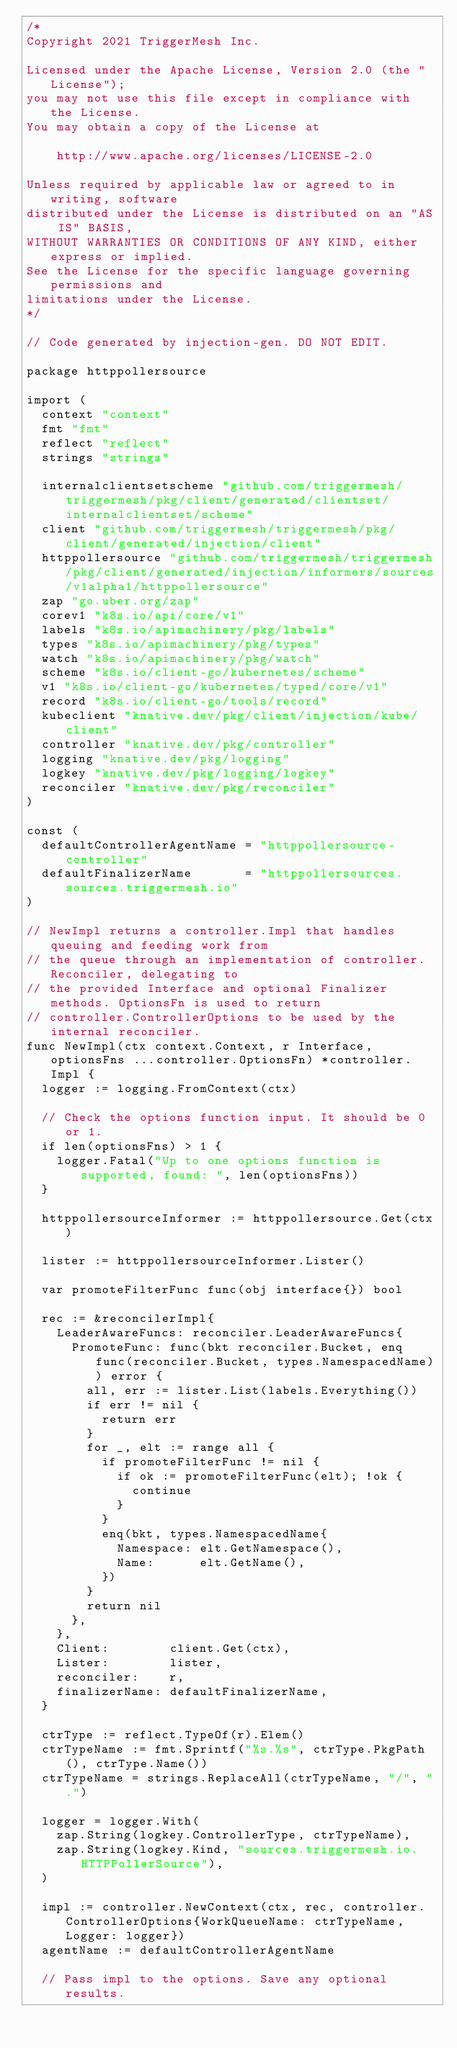Convert code to text. <code><loc_0><loc_0><loc_500><loc_500><_Go_>/*
Copyright 2021 TriggerMesh Inc.

Licensed under the Apache License, Version 2.0 (the "License");
you may not use this file except in compliance with the License.
You may obtain a copy of the License at

    http://www.apache.org/licenses/LICENSE-2.0

Unless required by applicable law or agreed to in writing, software
distributed under the License is distributed on an "AS IS" BASIS,
WITHOUT WARRANTIES OR CONDITIONS OF ANY KIND, either express or implied.
See the License for the specific language governing permissions and
limitations under the License.
*/

// Code generated by injection-gen. DO NOT EDIT.

package httppollersource

import (
	context "context"
	fmt "fmt"
	reflect "reflect"
	strings "strings"

	internalclientsetscheme "github.com/triggermesh/triggermesh/pkg/client/generated/clientset/internalclientset/scheme"
	client "github.com/triggermesh/triggermesh/pkg/client/generated/injection/client"
	httppollersource "github.com/triggermesh/triggermesh/pkg/client/generated/injection/informers/sources/v1alpha1/httppollersource"
	zap "go.uber.org/zap"
	corev1 "k8s.io/api/core/v1"
	labels "k8s.io/apimachinery/pkg/labels"
	types "k8s.io/apimachinery/pkg/types"
	watch "k8s.io/apimachinery/pkg/watch"
	scheme "k8s.io/client-go/kubernetes/scheme"
	v1 "k8s.io/client-go/kubernetes/typed/core/v1"
	record "k8s.io/client-go/tools/record"
	kubeclient "knative.dev/pkg/client/injection/kube/client"
	controller "knative.dev/pkg/controller"
	logging "knative.dev/pkg/logging"
	logkey "knative.dev/pkg/logging/logkey"
	reconciler "knative.dev/pkg/reconciler"
)

const (
	defaultControllerAgentName = "httppollersource-controller"
	defaultFinalizerName       = "httppollersources.sources.triggermesh.io"
)

// NewImpl returns a controller.Impl that handles queuing and feeding work from
// the queue through an implementation of controller.Reconciler, delegating to
// the provided Interface and optional Finalizer methods. OptionsFn is used to return
// controller.ControllerOptions to be used by the internal reconciler.
func NewImpl(ctx context.Context, r Interface, optionsFns ...controller.OptionsFn) *controller.Impl {
	logger := logging.FromContext(ctx)

	// Check the options function input. It should be 0 or 1.
	if len(optionsFns) > 1 {
		logger.Fatal("Up to one options function is supported, found: ", len(optionsFns))
	}

	httppollersourceInformer := httppollersource.Get(ctx)

	lister := httppollersourceInformer.Lister()

	var promoteFilterFunc func(obj interface{}) bool

	rec := &reconcilerImpl{
		LeaderAwareFuncs: reconciler.LeaderAwareFuncs{
			PromoteFunc: func(bkt reconciler.Bucket, enq func(reconciler.Bucket, types.NamespacedName)) error {
				all, err := lister.List(labels.Everything())
				if err != nil {
					return err
				}
				for _, elt := range all {
					if promoteFilterFunc != nil {
						if ok := promoteFilterFunc(elt); !ok {
							continue
						}
					}
					enq(bkt, types.NamespacedName{
						Namespace: elt.GetNamespace(),
						Name:      elt.GetName(),
					})
				}
				return nil
			},
		},
		Client:        client.Get(ctx),
		Lister:        lister,
		reconciler:    r,
		finalizerName: defaultFinalizerName,
	}

	ctrType := reflect.TypeOf(r).Elem()
	ctrTypeName := fmt.Sprintf("%s.%s", ctrType.PkgPath(), ctrType.Name())
	ctrTypeName = strings.ReplaceAll(ctrTypeName, "/", ".")

	logger = logger.With(
		zap.String(logkey.ControllerType, ctrTypeName),
		zap.String(logkey.Kind, "sources.triggermesh.io.HTTPPollerSource"),
	)

	impl := controller.NewContext(ctx, rec, controller.ControllerOptions{WorkQueueName: ctrTypeName, Logger: logger})
	agentName := defaultControllerAgentName

	// Pass impl to the options. Save any optional results.</code> 